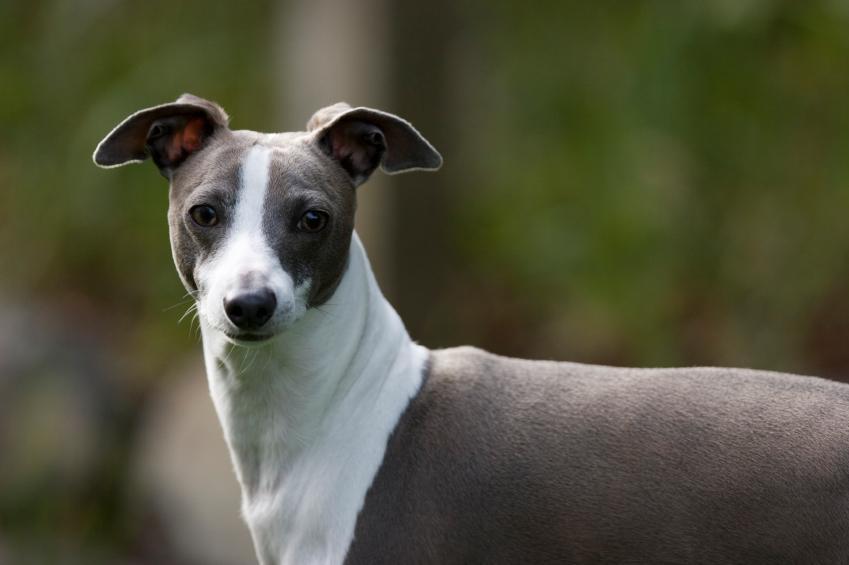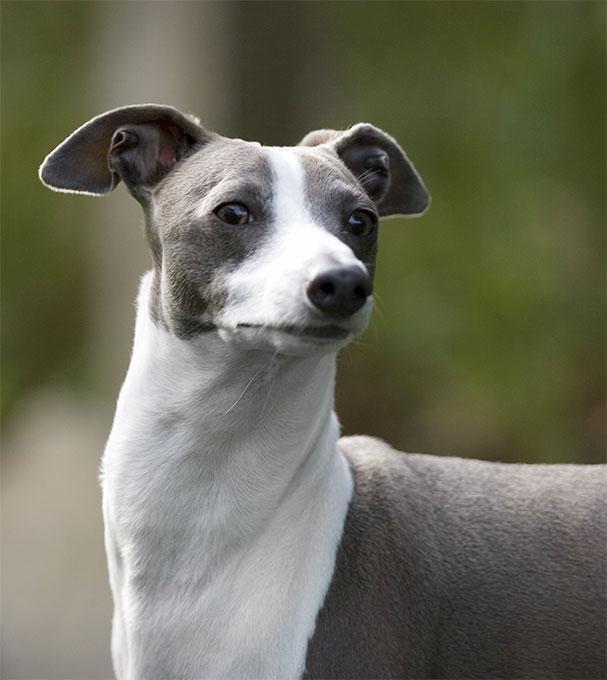The first image is the image on the left, the second image is the image on the right. Given the left and right images, does the statement "One dog has a collar on." hold true? Answer yes or no. No. 